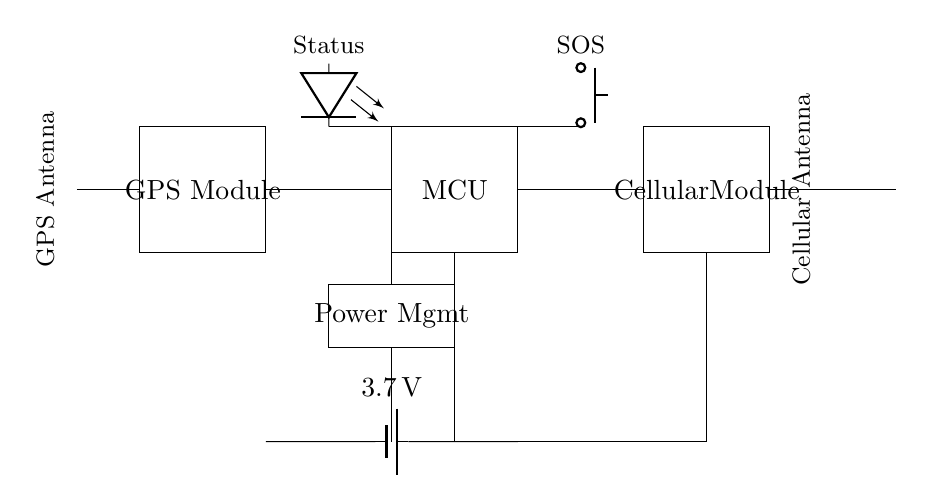What components are present in the circuit? The circuit contains a GPS Module, Microcontroller, Battery, Cellular Module, Antenna, Power Management, SOS Button, and Status LED. Each component is visually represented in the diagram.
Answer: GPS Module, Microcontroller, Battery, Cellular Module, Antenna, Power Management, SOS Button, Status LED What is the voltage of the battery? The battery is labeled with a voltage of three point seven volts in the circuit. This information comes directly from the battery symbol.
Answer: three point seven volts What is the function of the SOS button? The SOS button is designed to signal for help. It's connected to the Microcontroller, which indicates its role in sending alerts or notifications when pressed.
Answer: Signal for help How do the GPS and Cellular modules connect within the circuit? The GPS module connects to the Microcontroller directly, and from there, the Microcontroller connects to the Cellular Module, allowing communication between the GPS and cellular networks.
Answer: Through the Microcontroller What additional element provides power to the entire circuit? The Power Management component is crucial as it distributes the battery voltage to all components. It regulates power consumption to ensure each part receives adequate energy.
Answer: Power Management How do the antennas interact within the circuit? The GPS antenna and Cellular antenna connect to their respective modules, allowing GPS data transmission and cellular communication to take place simultaneously, ensuring effective tracking and communication.
Answer: Connect to modules What is the purpose of the Status LED? The Status LED indicates the operational state of the device, providing visual feedback on whether the device is powered on or functioning properly.
Answer: Indicate operational state 